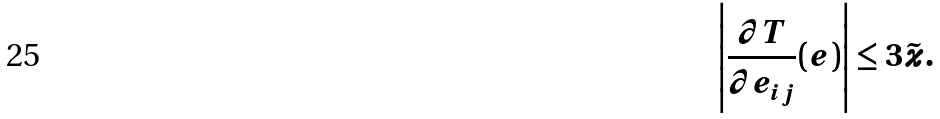<formula> <loc_0><loc_0><loc_500><loc_500>\left | \frac { \partial T } { \partial e _ { i j } } ( e ) \right | \leq 3 \tilde { \varkappa } .</formula> 